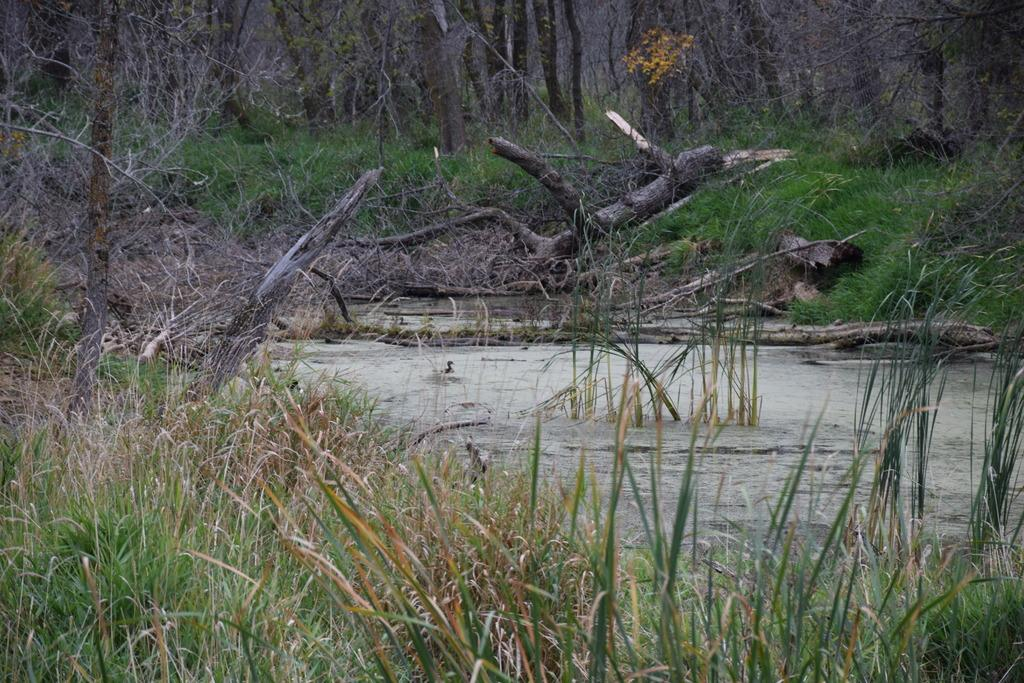What type of vegetation can be seen in the image? There are trees, plants, and grass visible in the image. What else can be seen in the image besides vegetation? There are trunks and water visible in the image. How many legs can be seen on the sugar in the image? There is no sugar present in the image, and therefore no legs can be seen. 